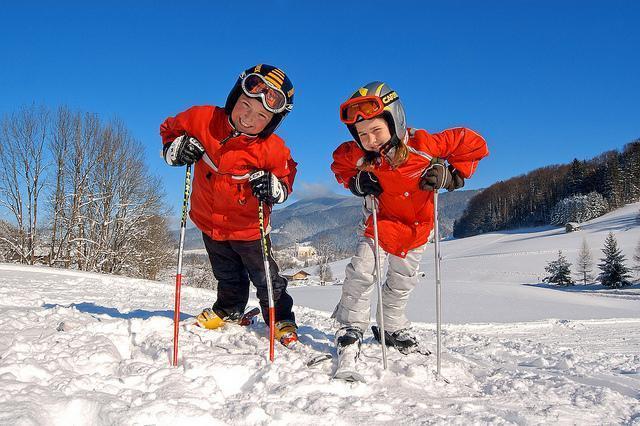How many children is there?
Give a very brief answer. 2. How many people are in the picture?
Give a very brief answer. 2. 